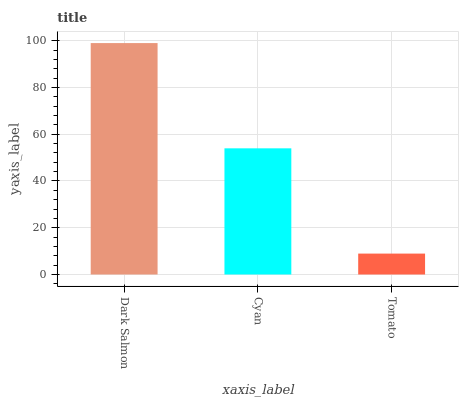Is Tomato the minimum?
Answer yes or no. Yes. Is Dark Salmon the maximum?
Answer yes or no. Yes. Is Cyan the minimum?
Answer yes or no. No. Is Cyan the maximum?
Answer yes or no. No. Is Dark Salmon greater than Cyan?
Answer yes or no. Yes. Is Cyan less than Dark Salmon?
Answer yes or no. Yes. Is Cyan greater than Dark Salmon?
Answer yes or no. No. Is Dark Salmon less than Cyan?
Answer yes or no. No. Is Cyan the high median?
Answer yes or no. Yes. Is Cyan the low median?
Answer yes or no. Yes. Is Tomato the high median?
Answer yes or no. No. Is Tomato the low median?
Answer yes or no. No. 